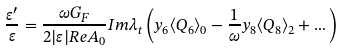Convert formula to latex. <formula><loc_0><loc_0><loc_500><loc_500>\frac { \varepsilon ^ { \prime } } { \varepsilon } = \frac { \omega G _ { F } } { 2 | \varepsilon | R e A _ { 0 } } I m \lambda _ { t } \left ( y _ { 6 } \langle Q _ { 6 } \rangle _ { 0 } - \frac { 1 } { \omega } y _ { 8 } \langle Q _ { 8 } \rangle _ { 2 } + \dots \right )</formula> 